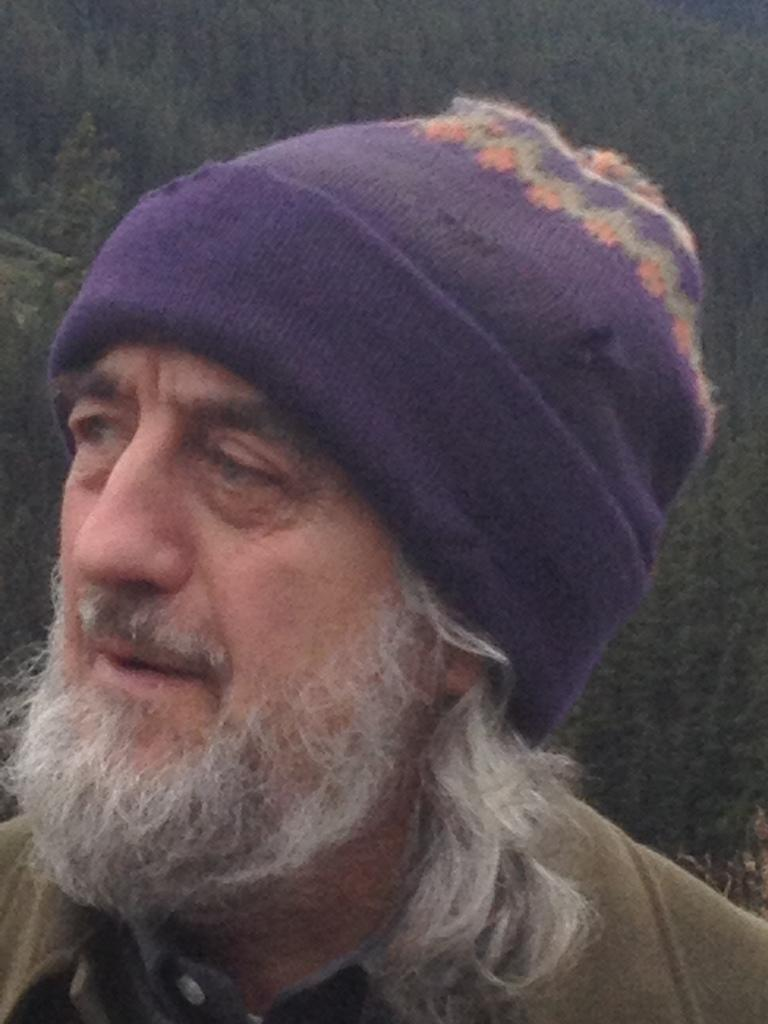Who is present in the image? There is a man in the picture. What is the man wearing on his head? The man is wearing a cap. What type of clothing is the man wearing? The man is wearing clothes. What type of stove can be seen in the image? There is no stove present in the image. Is the man riding a horse in the image? There is no horse present in the image. 